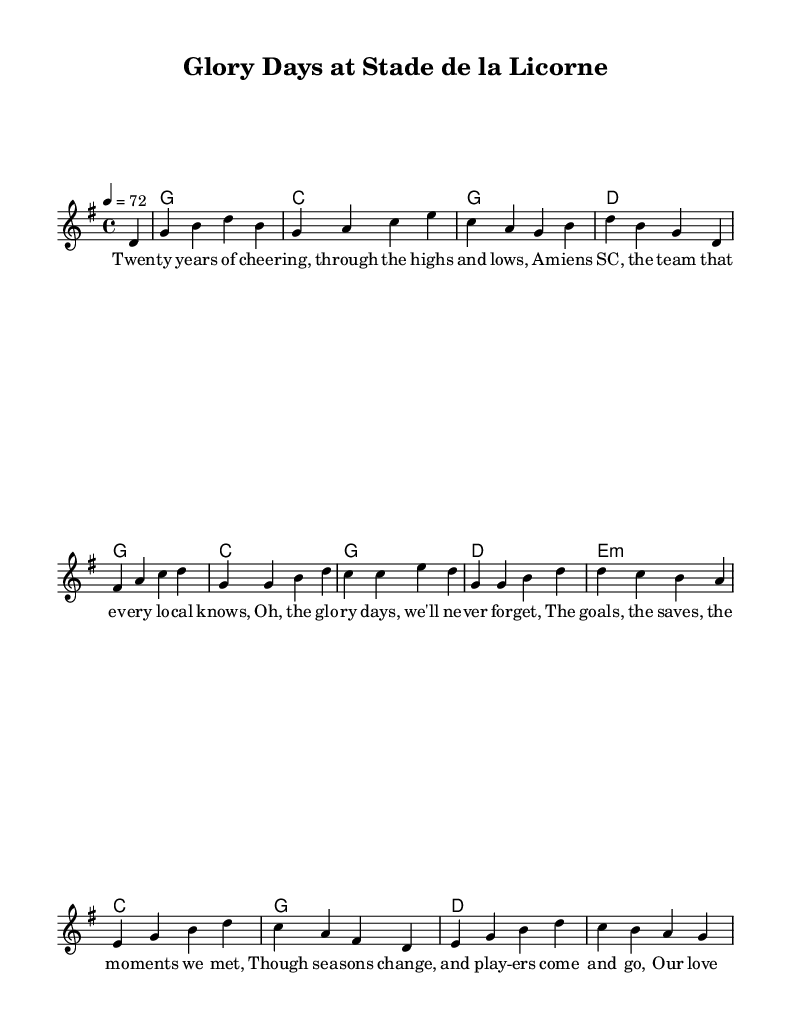What is the key signature of this music? The key signature is G major, which has one sharp (F#). I can identify this from the global declaration at the beginning of the score that states "\key g \major".
Answer: G major What is the time signature of this music? The time signature is 4/4, indicating four beats per measure. This information is found in the global section with "\time 4/4".
Answer: 4/4 What is the tempo marking indicated in the sheet music? The tempo marking is 72 beats per minute, as shown in the global section with "\tempo 4 = 72". This dictates the speed at which the piece should be played.
Answer: 72 How many bars are in the melody section? The melody section contains 8 bars. We can count each measure as indicated by the vertical bar lines in the melody notation.
Answer: 8 Which chord is played in the first bar? The chord played in the first bar is a G major chord, identifiable from the harmonies section that sets the first chord as "g1".
Answer: G How many verses are included in the lyrics of this piece? The piece contains only one verse, as there is a single lyrics block labeled "verseOne" in the score. There are no additional verses provided.
Answer: One What theme do the lyrics primarily reflect? The lyrics primarily reflect nostalgia for past football moments and the loyalty to Amiens SC. This is evident in the content of the lyrics, which recount memories of supporting the team.
Answer: Nostalgia 